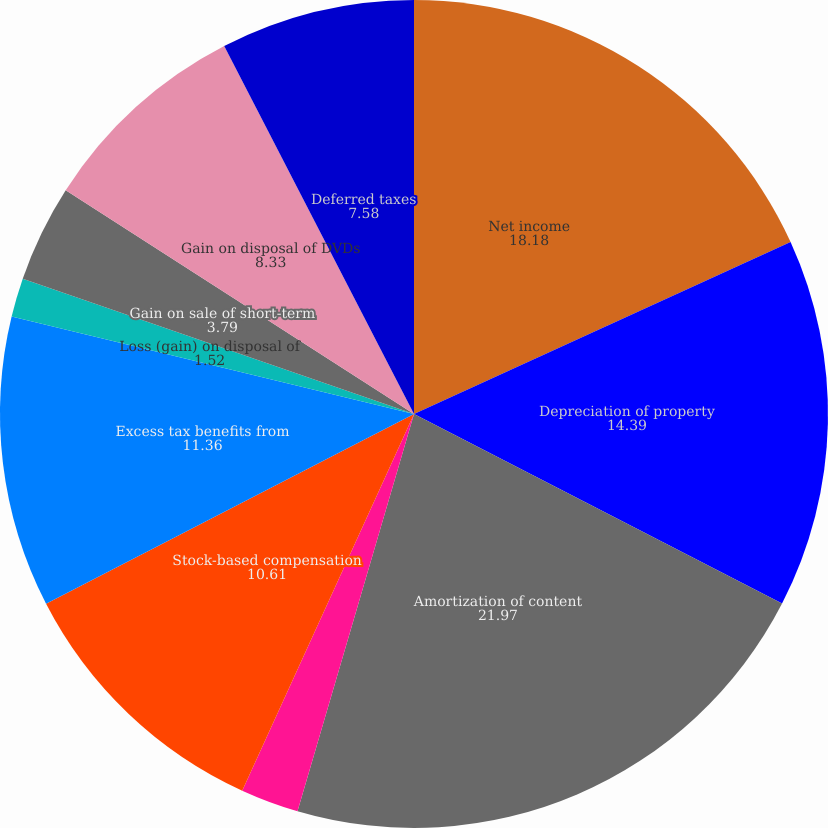<chart> <loc_0><loc_0><loc_500><loc_500><pie_chart><fcel>Net income<fcel>Depreciation of property<fcel>Amortization of content<fcel>Amortization of discounts and<fcel>Stock-based compensation<fcel>Excess tax benefits from<fcel>Loss (gain) on disposal of<fcel>Gain on sale of short-term<fcel>Gain on disposal of DVDs<fcel>Deferred taxes<nl><fcel>18.18%<fcel>14.39%<fcel>21.97%<fcel>2.27%<fcel>10.61%<fcel>11.36%<fcel>1.52%<fcel>3.79%<fcel>8.33%<fcel>7.58%<nl></chart> 